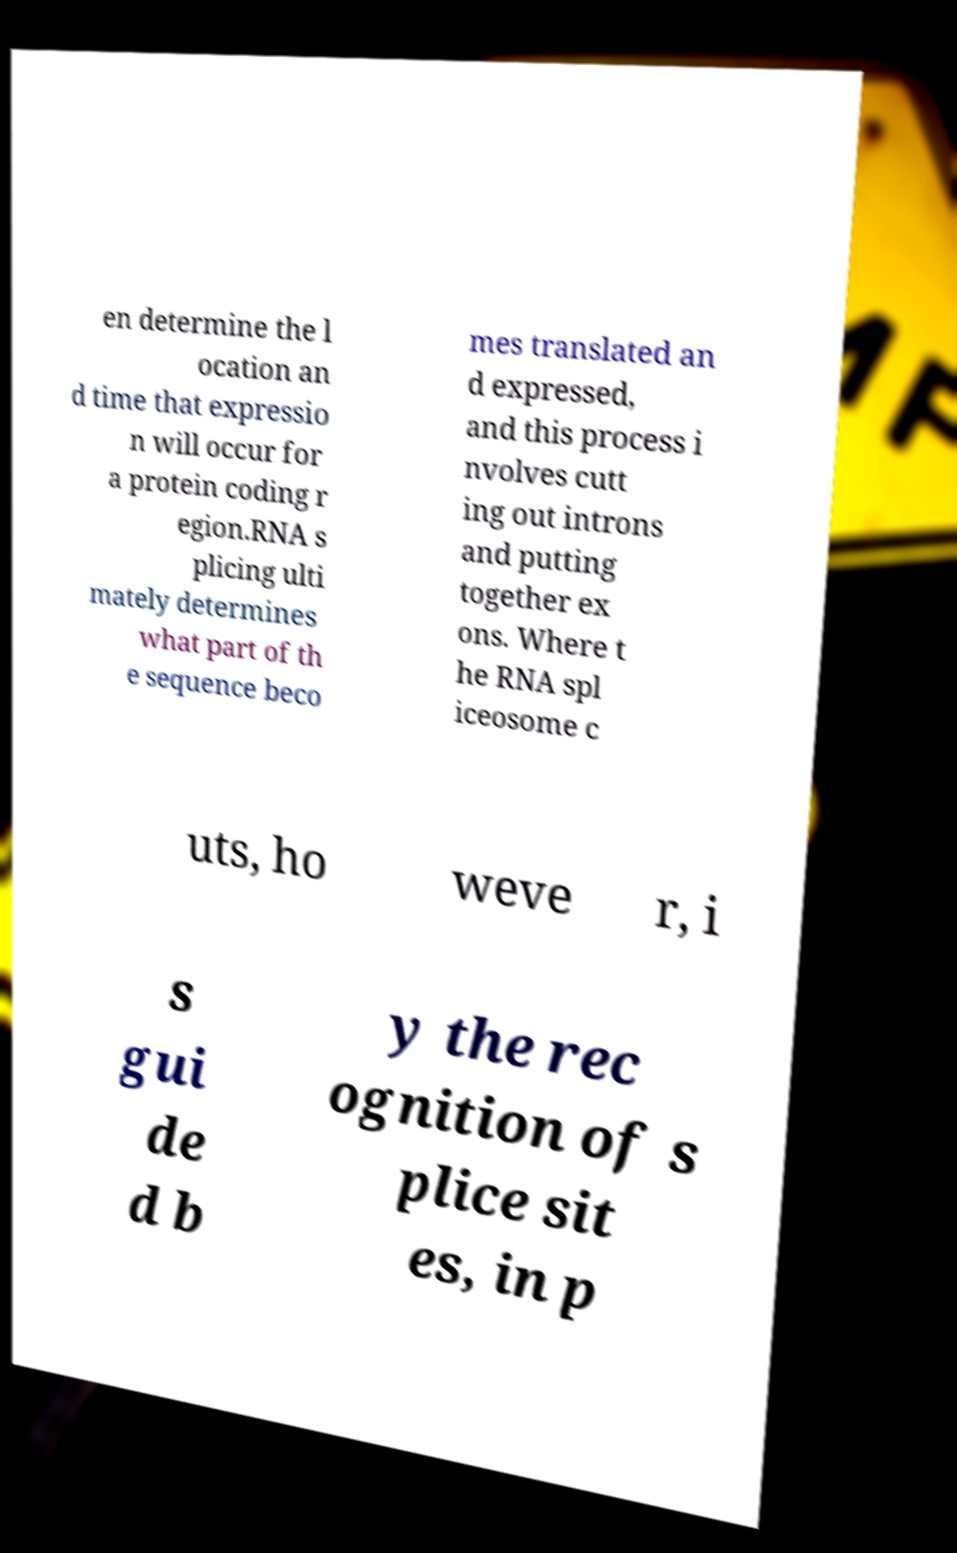For documentation purposes, I need the text within this image transcribed. Could you provide that? en determine the l ocation an d time that expressio n will occur for a protein coding r egion.RNA s plicing ulti mately determines what part of th e sequence beco mes translated an d expressed, and this process i nvolves cutt ing out introns and putting together ex ons. Where t he RNA spl iceosome c uts, ho weve r, i s gui de d b y the rec ognition of s plice sit es, in p 